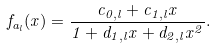Convert formula to latex. <formula><loc_0><loc_0><loc_500><loc_500>f _ { a _ { l } } ( x ) = \frac { c _ { 0 , l } + c _ { 1 , l } x } { 1 + d _ { 1 , l } x + d _ { 2 , l } x ^ { 2 } } .</formula> 